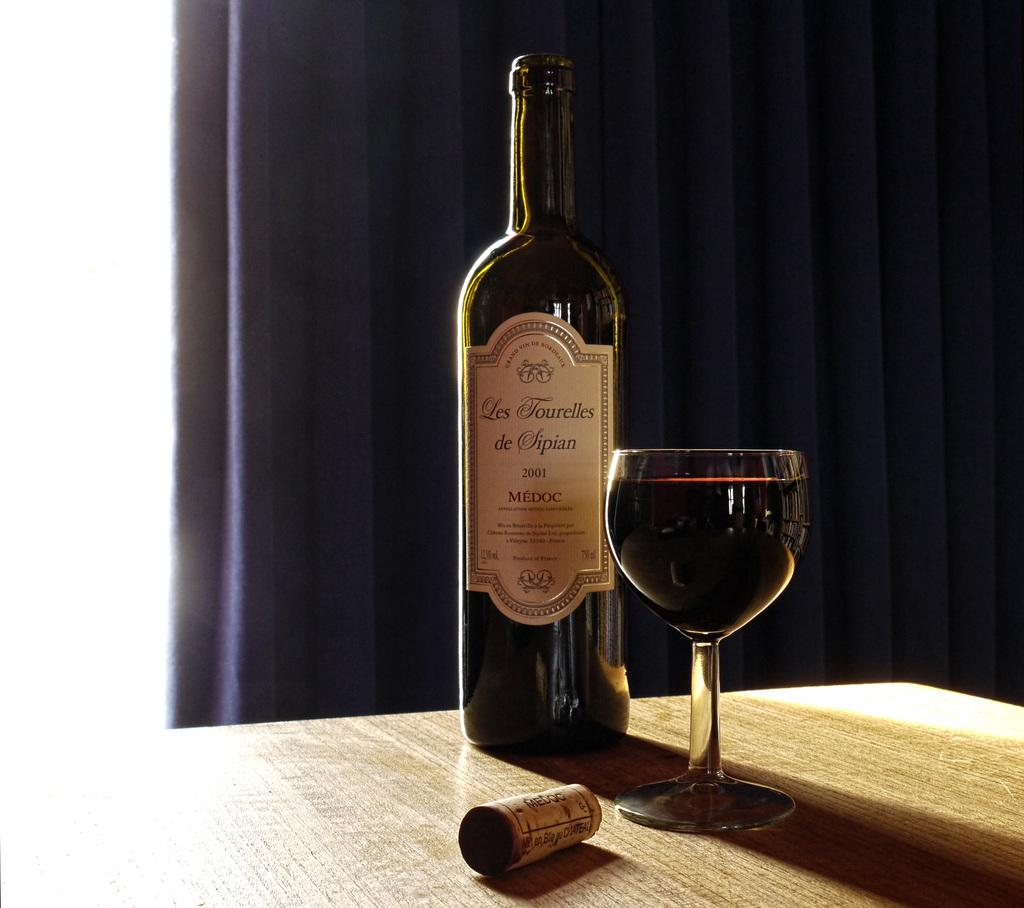<image>
Summarize the visual content of the image. Les Tourelles de Sipian sits on a wooden table open next to a full glass. 